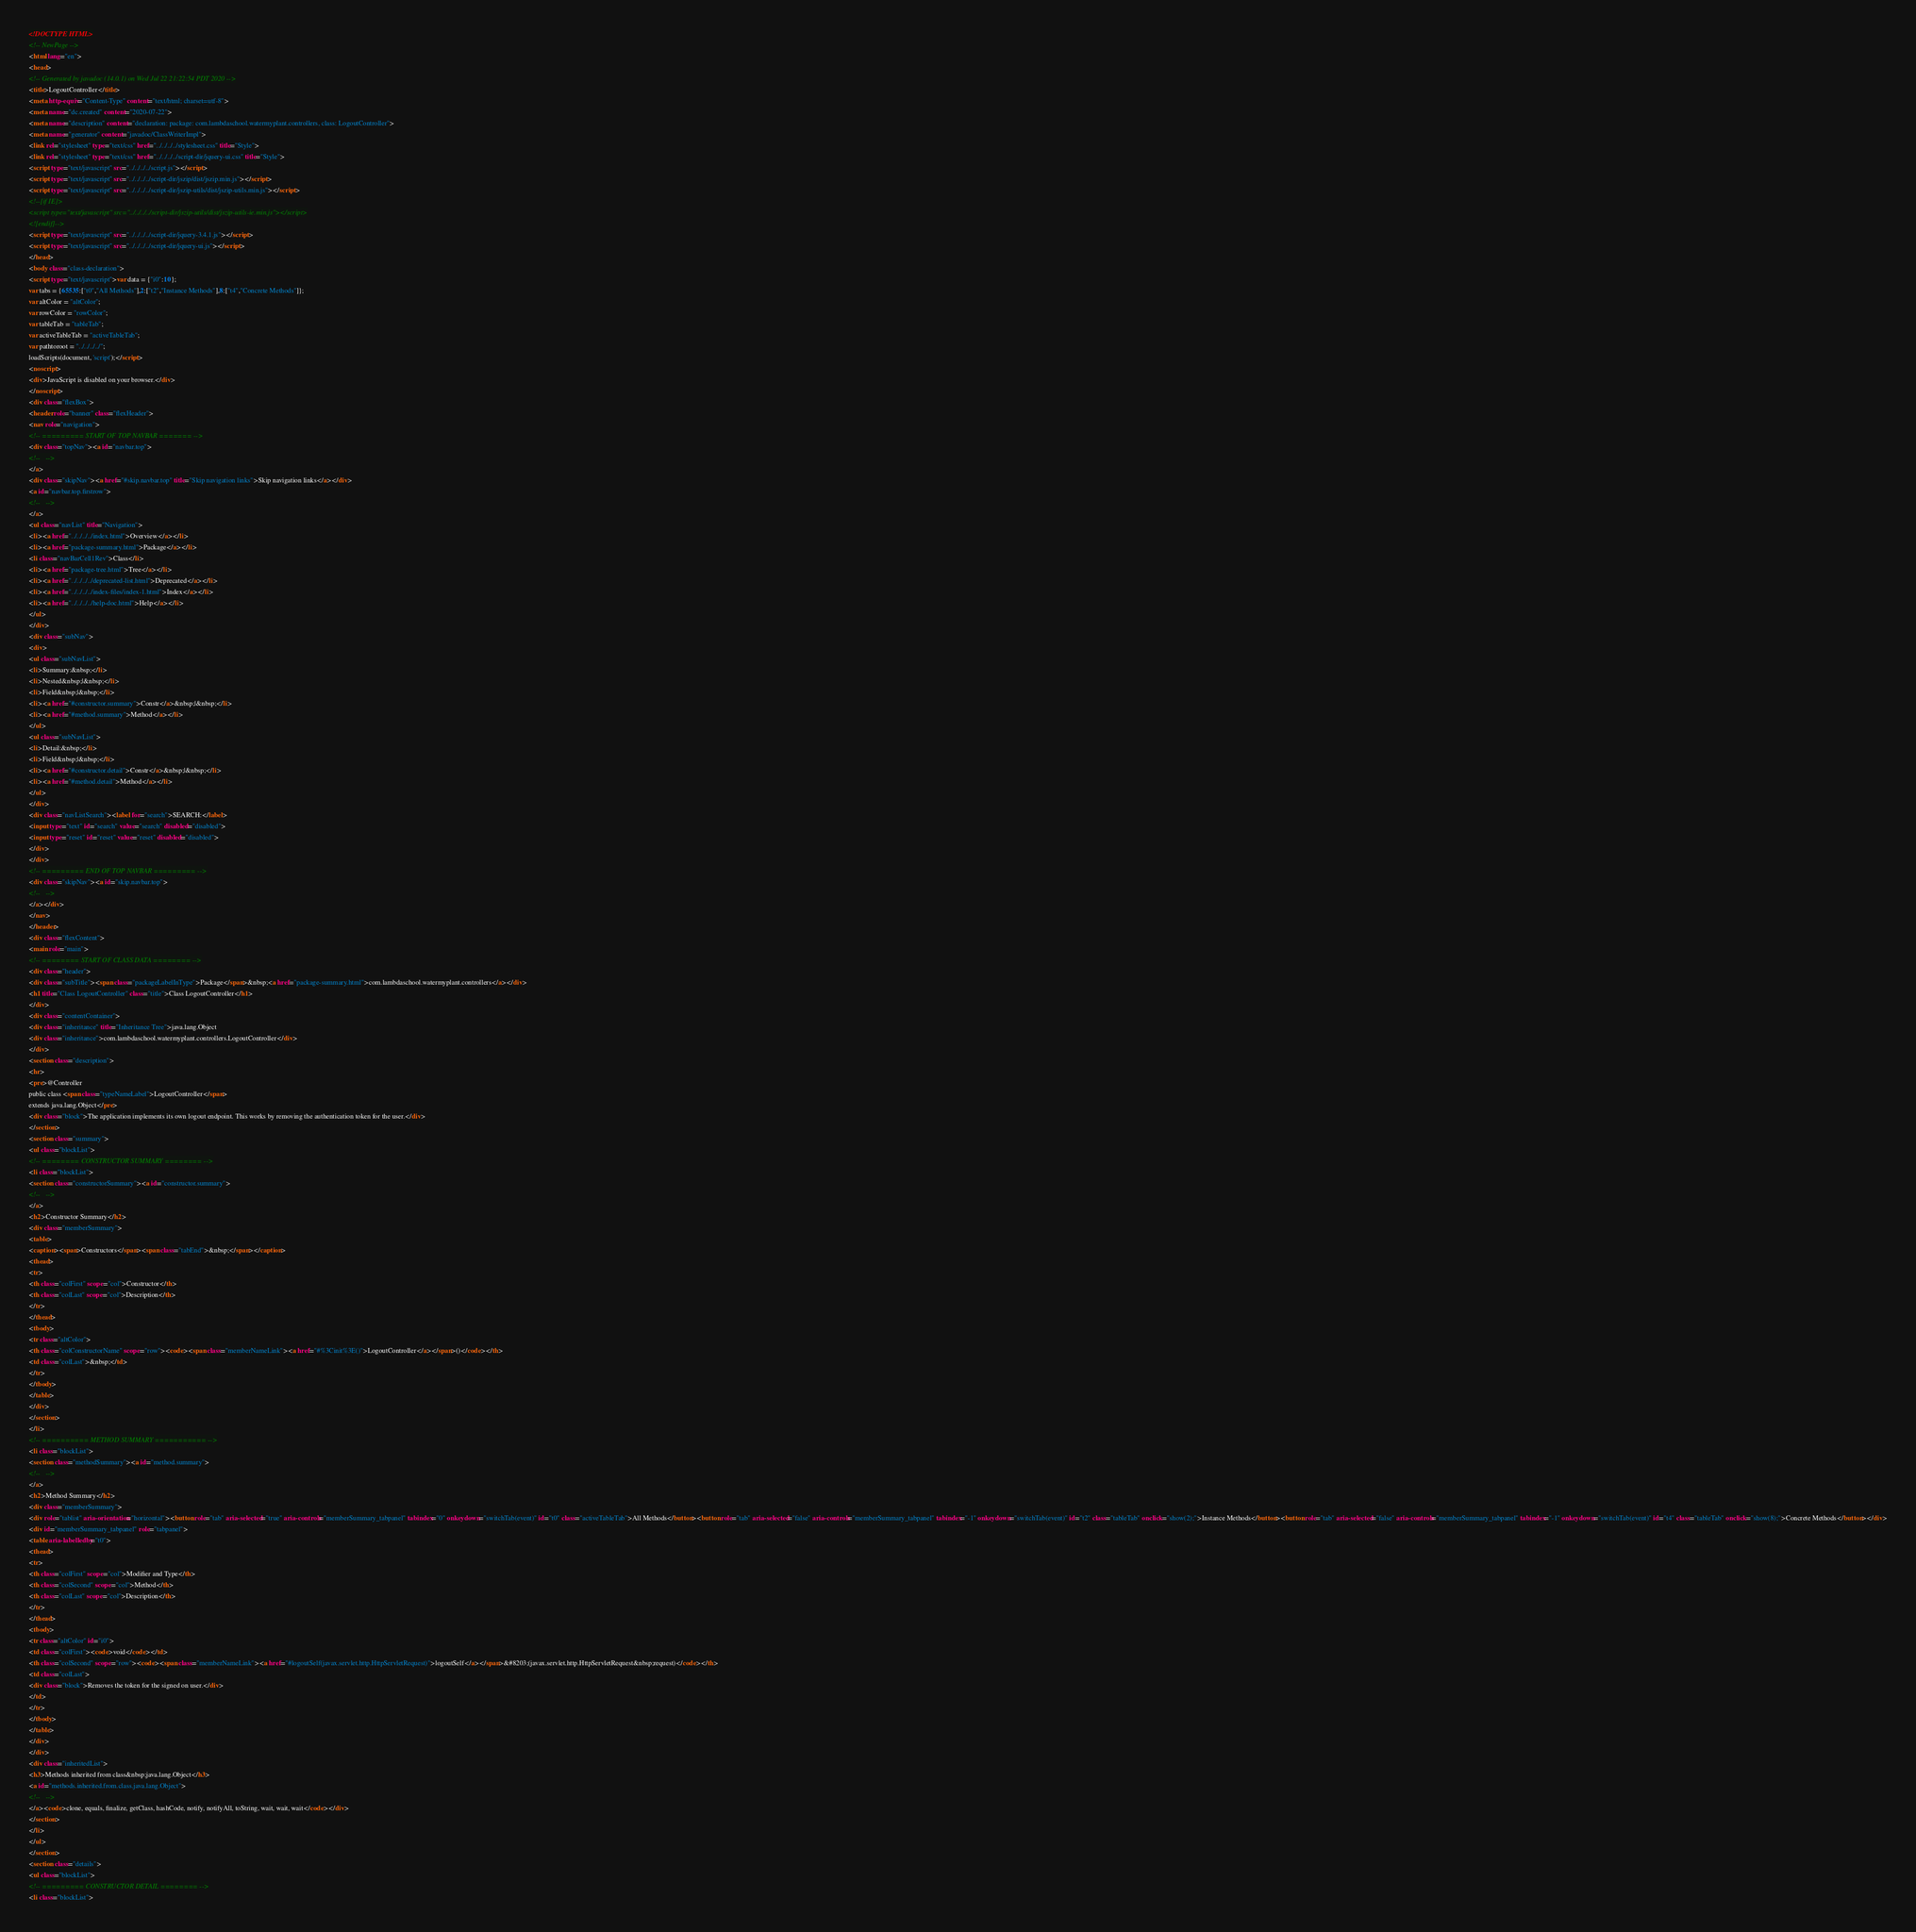<code> <loc_0><loc_0><loc_500><loc_500><_HTML_><!DOCTYPE HTML>
<!-- NewPage -->
<html lang="en">
<head>
<!-- Generated by javadoc (14.0.1) on Wed Jul 22 21:22:54 PDT 2020 -->
<title>LogoutController</title>
<meta http-equiv="Content-Type" content="text/html; charset=utf-8">
<meta name="dc.created" content="2020-07-22">
<meta name="description" content="declaration: package: com.lambdaschool.watermyplant.controllers, class: LogoutController">
<meta name="generator" content="javadoc/ClassWriterImpl">
<link rel="stylesheet" type="text/css" href="../../../../stylesheet.css" title="Style">
<link rel="stylesheet" type="text/css" href="../../../../script-dir/jquery-ui.css" title="Style">
<script type="text/javascript" src="../../../../script.js"></script>
<script type="text/javascript" src="../../../../script-dir/jszip/dist/jszip.min.js"></script>
<script type="text/javascript" src="../../../../script-dir/jszip-utils/dist/jszip-utils.min.js"></script>
<!--[if IE]>
<script type="text/javascript" src="../../../../script-dir/jszip-utils/dist/jszip-utils-ie.min.js"></script>
<![endif]-->
<script type="text/javascript" src="../../../../script-dir/jquery-3.4.1.js"></script>
<script type="text/javascript" src="../../../../script-dir/jquery-ui.js"></script>
</head>
<body class="class-declaration">
<script type="text/javascript">var data = {"i0":10};
var tabs = {65535:["t0","All Methods"],2:["t2","Instance Methods"],8:["t4","Concrete Methods"]};
var altColor = "altColor";
var rowColor = "rowColor";
var tableTab = "tableTab";
var activeTableTab = "activeTableTab";
var pathtoroot = "../../../../";
loadScripts(document, 'script');</script>
<noscript>
<div>JavaScript is disabled on your browser.</div>
</noscript>
<div class="flexBox">
<header role="banner" class="flexHeader">
<nav role="navigation">
<!-- ========= START OF TOP NAVBAR ======= -->
<div class="topNav"><a id="navbar.top">
<!--   -->
</a>
<div class="skipNav"><a href="#skip.navbar.top" title="Skip navigation links">Skip navigation links</a></div>
<a id="navbar.top.firstrow">
<!--   -->
</a>
<ul class="navList" title="Navigation">
<li><a href="../../../../index.html">Overview</a></li>
<li><a href="package-summary.html">Package</a></li>
<li class="navBarCell1Rev">Class</li>
<li><a href="package-tree.html">Tree</a></li>
<li><a href="../../../../deprecated-list.html">Deprecated</a></li>
<li><a href="../../../../index-files/index-1.html">Index</a></li>
<li><a href="../../../../help-doc.html">Help</a></li>
</ul>
</div>
<div class="subNav">
<div>
<ul class="subNavList">
<li>Summary:&nbsp;</li>
<li>Nested&nbsp;|&nbsp;</li>
<li>Field&nbsp;|&nbsp;</li>
<li><a href="#constructor.summary">Constr</a>&nbsp;|&nbsp;</li>
<li><a href="#method.summary">Method</a></li>
</ul>
<ul class="subNavList">
<li>Detail:&nbsp;</li>
<li>Field&nbsp;|&nbsp;</li>
<li><a href="#constructor.detail">Constr</a>&nbsp;|&nbsp;</li>
<li><a href="#method.detail">Method</a></li>
</ul>
</div>
<div class="navListSearch"><label for="search">SEARCH:</label>
<input type="text" id="search" value="search" disabled="disabled">
<input type="reset" id="reset" value="reset" disabled="disabled">
</div>
</div>
<!-- ========= END OF TOP NAVBAR ========= -->
<div class="skipNav"><a id="skip.navbar.top">
<!--   -->
</a></div>
</nav>
</header>
<div class="flexContent">
<main role="main">
<!-- ======== START OF CLASS DATA ======== -->
<div class="header">
<div class="subTitle"><span class="packageLabelInType">Package</span>&nbsp;<a href="package-summary.html">com.lambdaschool.watermyplant.controllers</a></div>
<h1 title="Class LogoutController" class="title">Class LogoutController</h1>
</div>
<div class="contentContainer">
<div class="inheritance" title="Inheritance Tree">java.lang.Object
<div class="inheritance">com.lambdaschool.watermyplant.controllers.LogoutController</div>
</div>
<section class="description">
<hr>
<pre>@Controller
public class <span class="typeNameLabel">LogoutController</span>
extends java.lang.Object</pre>
<div class="block">The application implements its own logout endpoint. This works by removing the authentication token for the user.</div>
</section>
<section class="summary">
<ul class="blockList">
<!-- ======== CONSTRUCTOR SUMMARY ======== -->
<li class="blockList">
<section class="constructorSummary"><a id="constructor.summary">
<!--   -->
</a>
<h2>Constructor Summary</h2>
<div class="memberSummary">
<table>
<caption><span>Constructors</span><span class="tabEnd">&nbsp;</span></caption>
<thead>
<tr>
<th class="colFirst" scope="col">Constructor</th>
<th class="colLast" scope="col">Description</th>
</tr>
</thead>
<tbody>
<tr class="altColor">
<th class="colConstructorName" scope="row"><code><span class="memberNameLink"><a href="#%3Cinit%3E()">LogoutController</a></span>()</code></th>
<td class="colLast">&nbsp;</td>
</tr>
</tbody>
</table>
</div>
</section>
</li>
<!-- ========== METHOD SUMMARY =========== -->
<li class="blockList">
<section class="methodSummary"><a id="method.summary">
<!--   -->
</a>
<h2>Method Summary</h2>
<div class="memberSummary">
<div role="tablist" aria-orientation="horizontal"><button role="tab" aria-selected="true" aria-controls="memberSummary_tabpanel" tabindex="0" onkeydown="switchTab(event)" id="t0" class="activeTableTab">All Methods</button><button role="tab" aria-selected="false" aria-controls="memberSummary_tabpanel" tabindex="-1" onkeydown="switchTab(event)" id="t2" class="tableTab" onclick="show(2);">Instance Methods</button><button role="tab" aria-selected="false" aria-controls="memberSummary_tabpanel" tabindex="-1" onkeydown="switchTab(event)" id="t4" class="tableTab" onclick="show(8);">Concrete Methods</button></div>
<div id="memberSummary_tabpanel" role="tabpanel">
<table aria-labelledby="t0">
<thead>
<tr>
<th class="colFirst" scope="col">Modifier and Type</th>
<th class="colSecond" scope="col">Method</th>
<th class="colLast" scope="col">Description</th>
</tr>
</thead>
<tbody>
<tr class="altColor" id="i0">
<td class="colFirst"><code>void</code></td>
<th class="colSecond" scope="row"><code><span class="memberNameLink"><a href="#logoutSelf(javax.servlet.http.HttpServletRequest)">logoutSelf</a></span>&#8203;(javax.servlet.http.HttpServletRequest&nbsp;request)</code></th>
<td class="colLast">
<div class="block">Removes the token for the signed on user.</div>
</td>
</tr>
</tbody>
</table>
</div>
</div>
<div class="inheritedList">
<h3>Methods inherited from class&nbsp;java.lang.Object</h3>
<a id="methods.inherited.from.class.java.lang.Object">
<!--   -->
</a><code>clone, equals, finalize, getClass, hashCode, notify, notifyAll, toString, wait, wait, wait</code></div>
</section>
</li>
</ul>
</section>
<section class="details">
<ul class="blockList">
<!-- ========= CONSTRUCTOR DETAIL ======== -->
<li class="blockList"></code> 